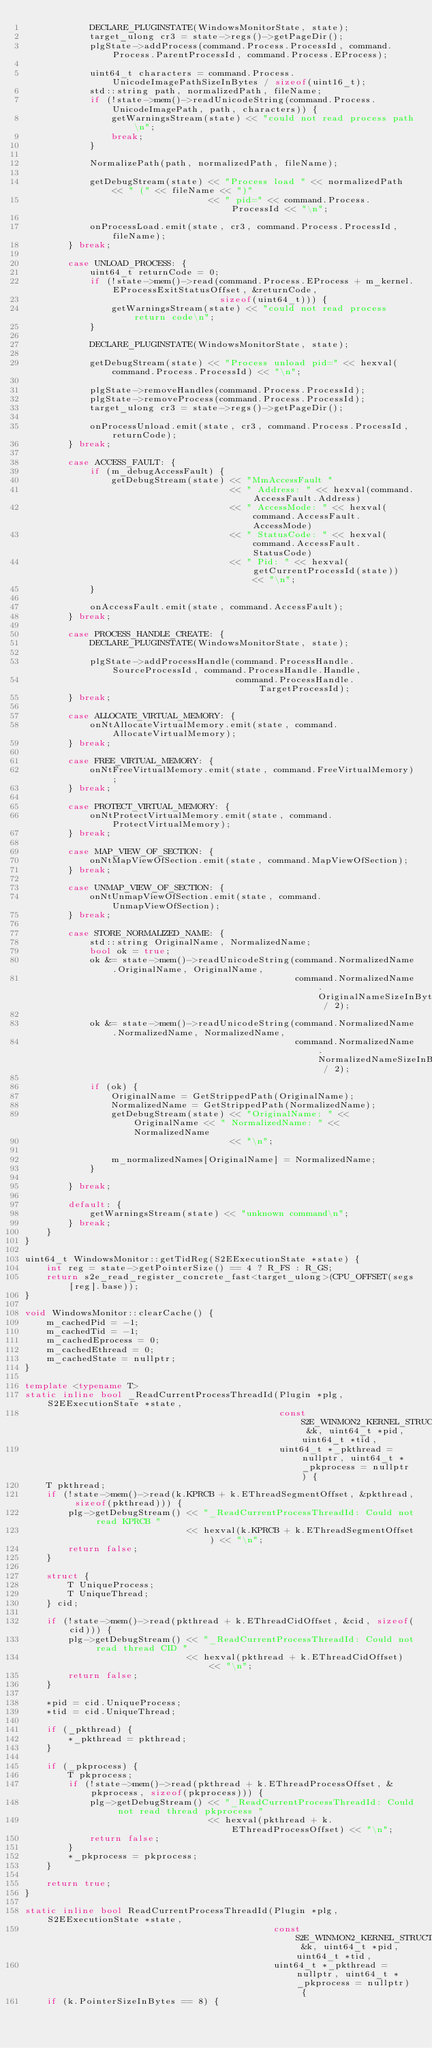<code> <loc_0><loc_0><loc_500><loc_500><_C++_>            DECLARE_PLUGINSTATE(WindowsMonitorState, state);
            target_ulong cr3 = state->regs()->getPageDir();
            plgState->addProcess(command.Process.ProcessId, command.Process.ParentProcessId, command.Process.EProcess);

            uint64_t characters = command.Process.UnicodeImagePathSizeInBytes / sizeof(uint16_t);
            std::string path, normalizedPath, fileName;
            if (!state->mem()->readUnicodeString(command.Process.UnicodeImagePath, path, characters)) {
                getWarningsStream(state) << "could not read process path\n";
                break;
            }

            NormalizePath(path, normalizedPath, fileName);

            getDebugStream(state) << "Process load " << normalizedPath << " (" << fileName << ")"
                                  << " pid=" << command.Process.ProcessId << "\n";

            onProcessLoad.emit(state, cr3, command.Process.ProcessId, fileName);
        } break;

        case UNLOAD_PROCESS: {
            uint64_t returnCode = 0;
            if (!state->mem()->read(command.Process.EProcess + m_kernel.EProcessExitStatusOffset, &returnCode,
                                    sizeof(uint64_t))) {
                getWarningsStream(state) << "could not read process return code\n";
            }

            DECLARE_PLUGINSTATE(WindowsMonitorState, state);

            getDebugStream(state) << "Process unload pid=" << hexval(command.Process.ProcessId) << "\n";

            plgState->removeHandles(command.Process.ProcessId);
            plgState->removeProcess(command.Process.ProcessId);
            target_ulong cr3 = state->regs()->getPageDir();

            onProcessUnload.emit(state, cr3, command.Process.ProcessId, returnCode);
        } break;

        case ACCESS_FAULT: {
            if (m_debugAccessFault) {
                getDebugStream(state) << "MmAccessFault "
                                      << " Address: " << hexval(command.AccessFault.Address)
                                      << " AccessMode: " << hexval(command.AccessFault.AccessMode)
                                      << " StatusCode: " << hexval(command.AccessFault.StatusCode)
                                      << " Pid: " << hexval(getCurrentProcessId(state)) << "\n";
            }

            onAccessFault.emit(state, command.AccessFault);
        } break;

        case PROCESS_HANDLE_CREATE: {
            DECLARE_PLUGINSTATE(WindowsMonitorState, state);

            plgState->addProcessHandle(command.ProcessHandle.SourceProcessId, command.ProcessHandle.Handle,
                                       command.ProcessHandle.TargetProcessId);
        } break;

        case ALLOCATE_VIRTUAL_MEMORY: {
            onNtAllocateVirtualMemory.emit(state, command.AllocateVirtualMemory);
        } break;

        case FREE_VIRTUAL_MEMORY: {
            onNtFreeVirtualMemory.emit(state, command.FreeVirtualMemory);
        } break;

        case PROTECT_VIRTUAL_MEMORY: {
            onNtProtectVirtualMemory.emit(state, command.ProtectVirtualMemory);
        } break;

        case MAP_VIEW_OF_SECTION: {
            onNtMapViewOfSection.emit(state, command.MapViewOfSection);
        } break;

        case UNMAP_VIEW_OF_SECTION: {
            onNtUnmapViewOfSection.emit(state, command.UnmapViewOfSection);
        } break;

        case STORE_NORMALIZED_NAME: {
            std::string OriginalName, NormalizedName;
            bool ok = true;
            ok &= state->mem()->readUnicodeString(command.NormalizedName.OriginalName, OriginalName,
                                                  command.NormalizedName.OriginalNameSizeInBytes / 2);

            ok &= state->mem()->readUnicodeString(command.NormalizedName.NormalizedName, NormalizedName,
                                                  command.NormalizedName.NormalizedNameSizeInBytes / 2);

            if (ok) {
                OriginalName = GetStrippedPath(OriginalName);
                NormalizedName = GetStrippedPath(NormalizedName);
                getDebugStream(state) << "OriginalName: " << OriginalName << " NormalizedName: " << NormalizedName
                                      << "\n";

                m_normalizedNames[OriginalName] = NormalizedName;
            }

        } break;

        default: {
            getWarningsStream(state) << "unknown command\n";
        } break;
    }
}

uint64_t WindowsMonitor::getTidReg(S2EExecutionState *state) {
    int reg = state->getPointerSize() == 4 ? R_FS : R_GS;
    return s2e_read_register_concrete_fast<target_ulong>(CPU_OFFSET(segs[reg].base));
}

void WindowsMonitor::clearCache() {
    m_cachedPid = -1;
    m_cachedTid = -1;
    m_cachedEprocess = 0;
    m_cachedEthread = 0;
    m_cachedState = nullptr;
}

template <typename T>
static inline bool _ReadCurrentProcessThreadId(Plugin *plg, S2EExecutionState *state,
                                               const S2E_WINMON2_KERNEL_STRUCTS &k, uint64_t *pid, uint64_t *tid,
                                               uint64_t *_pkthread = nullptr, uint64_t *_pkprocess = nullptr) {
    T pkthread;
    if (!state->mem()->read(k.KPRCB + k.EThreadSegmentOffset, &pkthread, sizeof(pkthread))) {
        plg->getDebugStream() << "_ReadCurrentProcessThreadId: Could not read KPRCB "
                              << hexval(k.KPRCB + k.EThreadSegmentOffset) << "\n";
        return false;
    }

    struct {
        T UniqueProcess;
        T UniqueThread;
    } cid;

    if (!state->mem()->read(pkthread + k.EThreadCidOffset, &cid, sizeof(cid))) {
        plg->getDebugStream() << "_ReadCurrentProcessThreadId: Could not read thread CID "
                              << hexval(pkthread + k.EThreadCidOffset) << "\n";
        return false;
    }

    *pid = cid.UniqueProcess;
    *tid = cid.UniqueThread;

    if (_pkthread) {
        *_pkthread = pkthread;
    }

    if (_pkprocess) {
        T pkprocess;
        if (!state->mem()->read(pkthread + k.EThreadProcessOffset, &pkprocess, sizeof(pkprocess))) {
            plg->getDebugStream() << "_ReadCurrentProcessThreadId: Could not read thread pkprocess "
                                  << hexval(pkthread + k.EThreadProcessOffset) << "\n";
            return false;
        }
        *_pkprocess = pkprocess;
    }

    return true;
}

static inline bool ReadCurrentProcessThreadId(Plugin *plg, S2EExecutionState *state,
                                              const S2E_WINMON2_KERNEL_STRUCTS &k, uint64_t *pid, uint64_t *tid,
                                              uint64_t *_pkthread = nullptr, uint64_t *_pkprocess = nullptr) {
    if (k.PointerSizeInBytes == 8) {</code> 